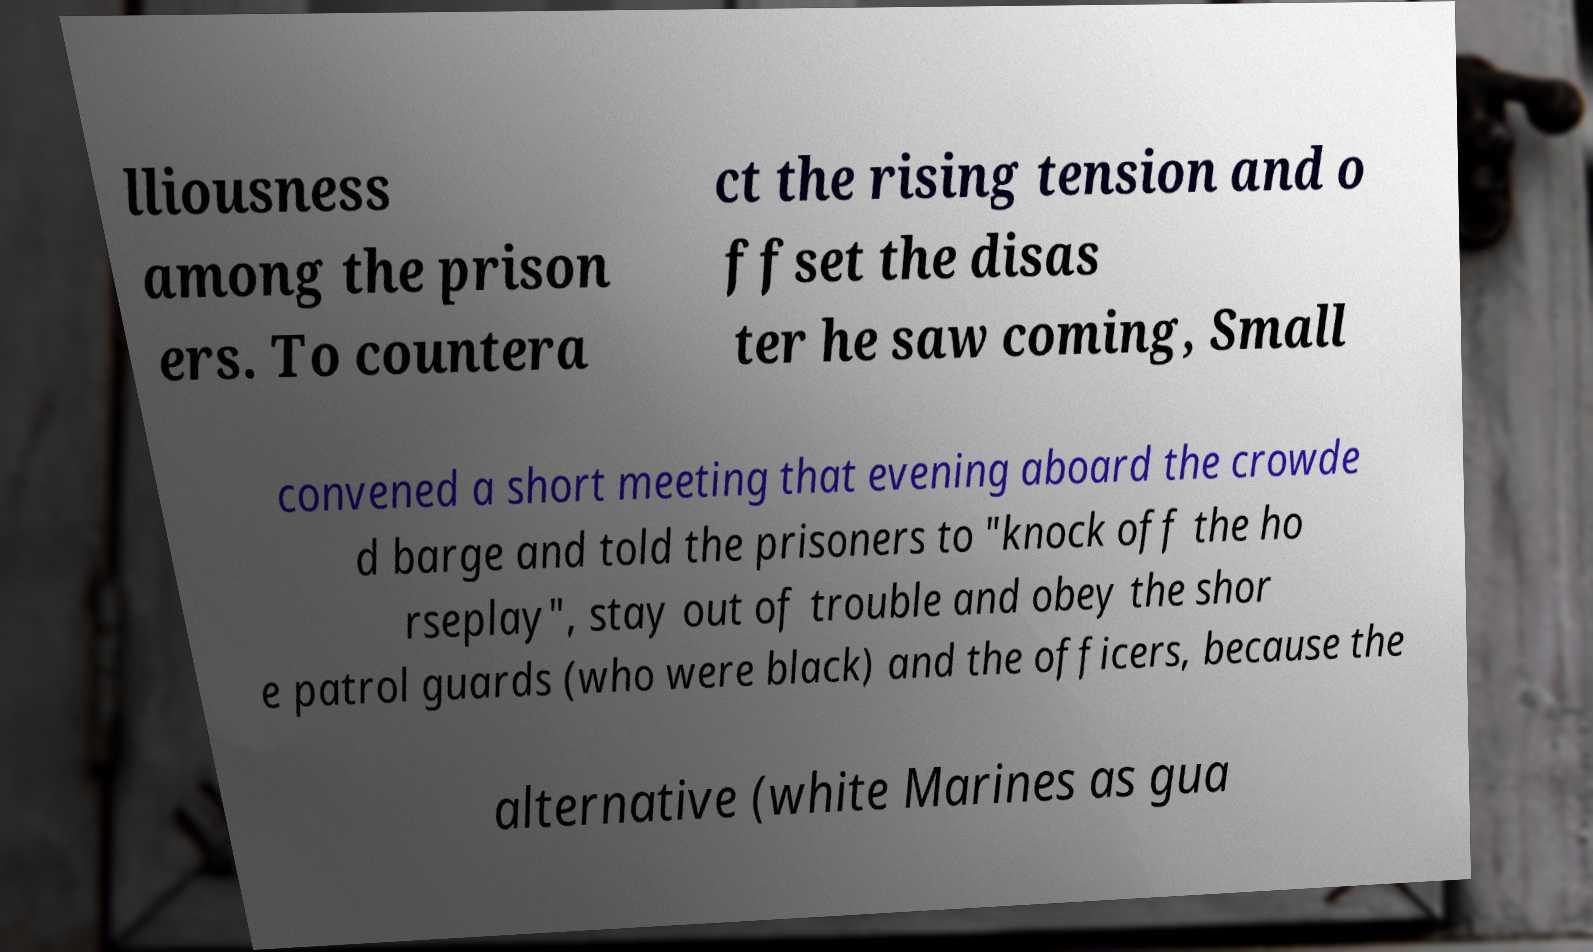Could you assist in decoding the text presented in this image and type it out clearly? lliousness among the prison ers. To countera ct the rising tension and o ffset the disas ter he saw coming, Small convened a short meeting that evening aboard the crowde d barge and told the prisoners to "knock off the ho rseplay", stay out of trouble and obey the shor e patrol guards (who were black) and the officers, because the alternative (white Marines as gua 